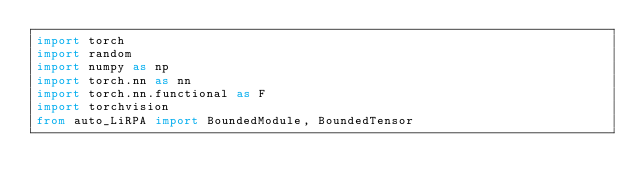Convert code to text. <code><loc_0><loc_0><loc_500><loc_500><_Python_>import torch
import random
import numpy as np
import torch.nn as nn
import torch.nn.functional as F
import torchvision
from auto_LiRPA import BoundedModule, BoundedTensor</code> 